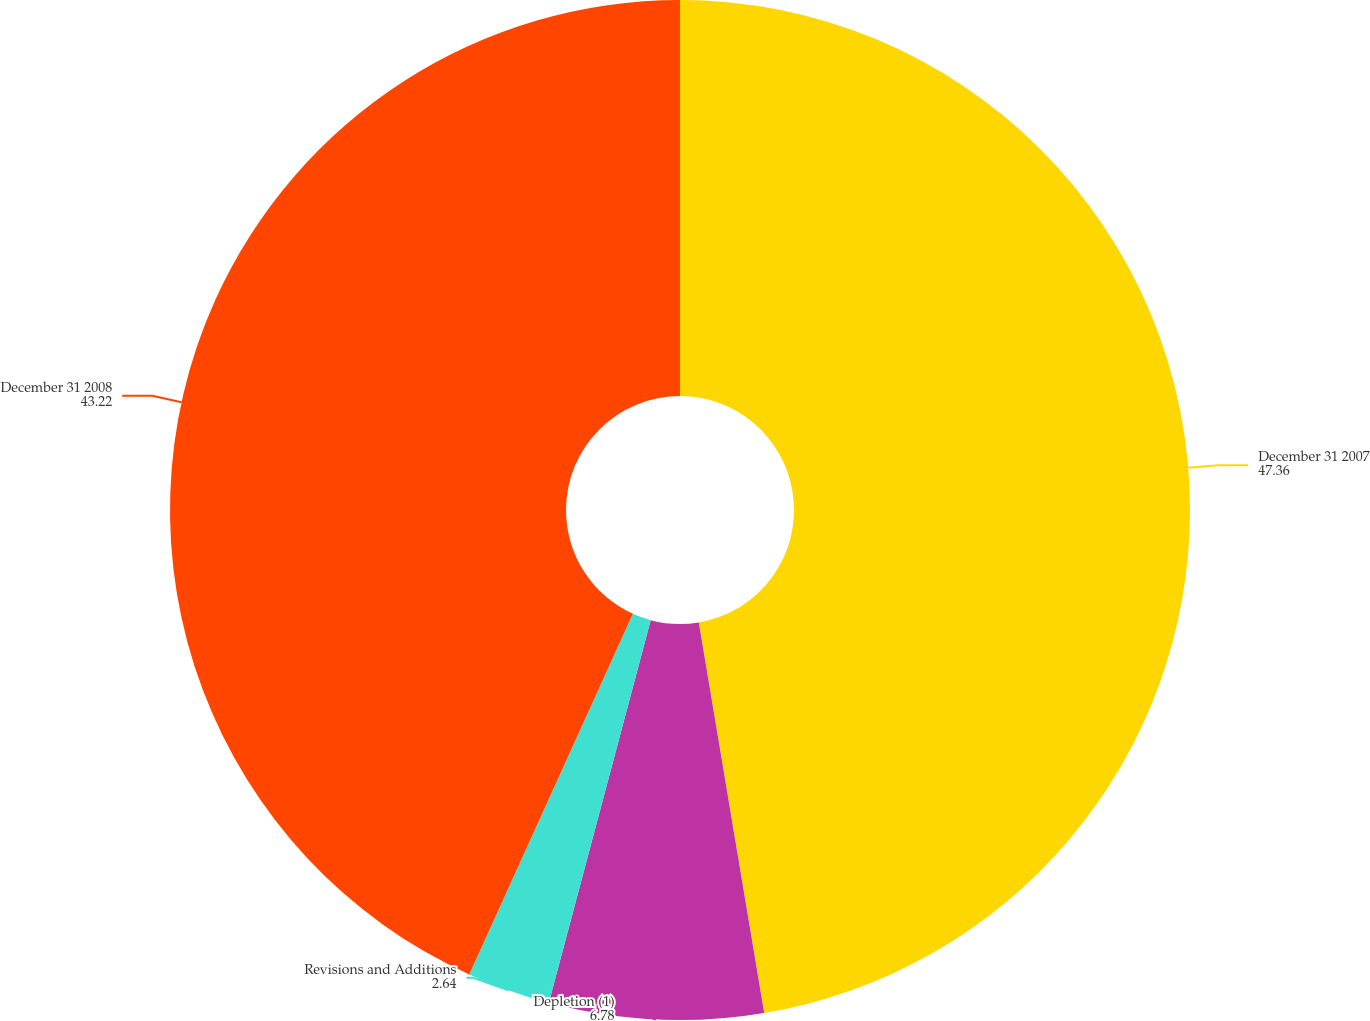Convert chart to OTSL. <chart><loc_0><loc_0><loc_500><loc_500><pie_chart><fcel>December 31 2007<fcel>Depletion (1)<fcel>Revisions and Additions<fcel>December 31 2008<nl><fcel>47.36%<fcel>6.78%<fcel>2.64%<fcel>43.22%<nl></chart> 